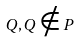<formula> <loc_0><loc_0><loc_500><loc_500>Q , Q \notin P</formula> 